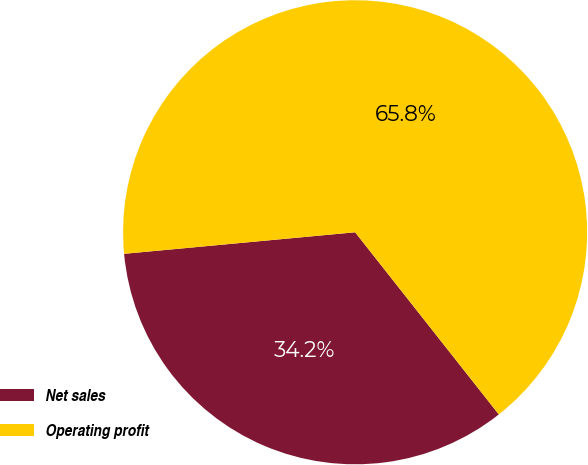<chart> <loc_0><loc_0><loc_500><loc_500><pie_chart><fcel>Net sales<fcel>Operating profit<nl><fcel>34.15%<fcel>65.85%<nl></chart> 